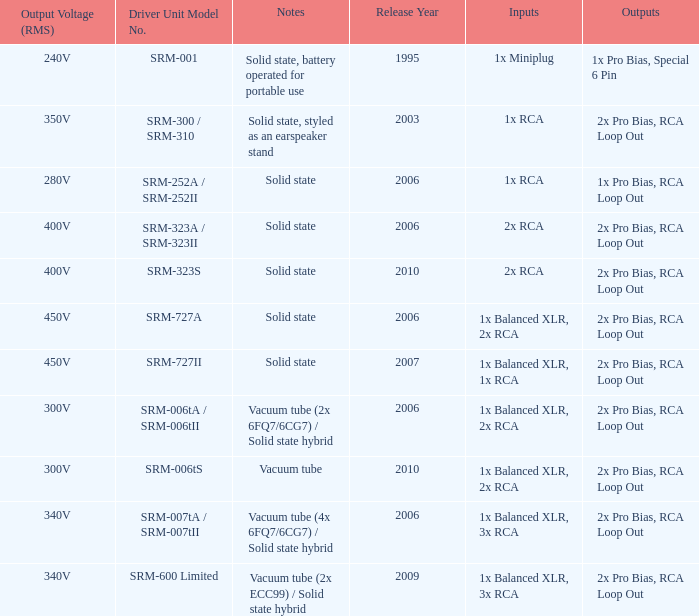How many outputs are there for solid state, battery operated for portable use listed in notes? 1.0. 